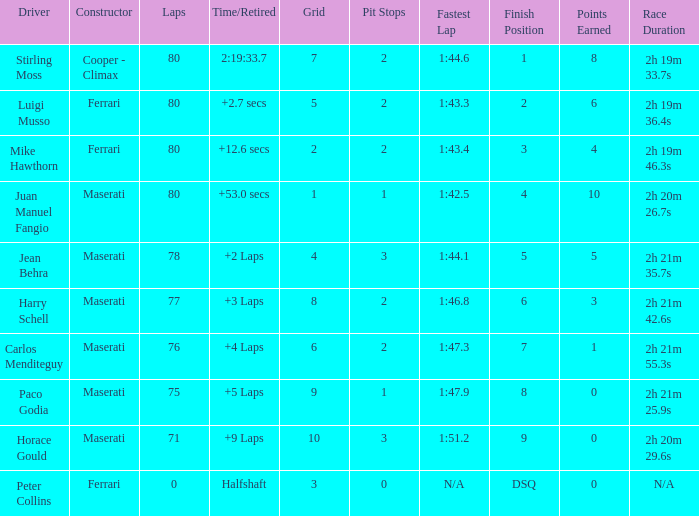What were the lowest laps of Luigi Musso driving a Ferrari with a Grid larger than 2? 80.0. 